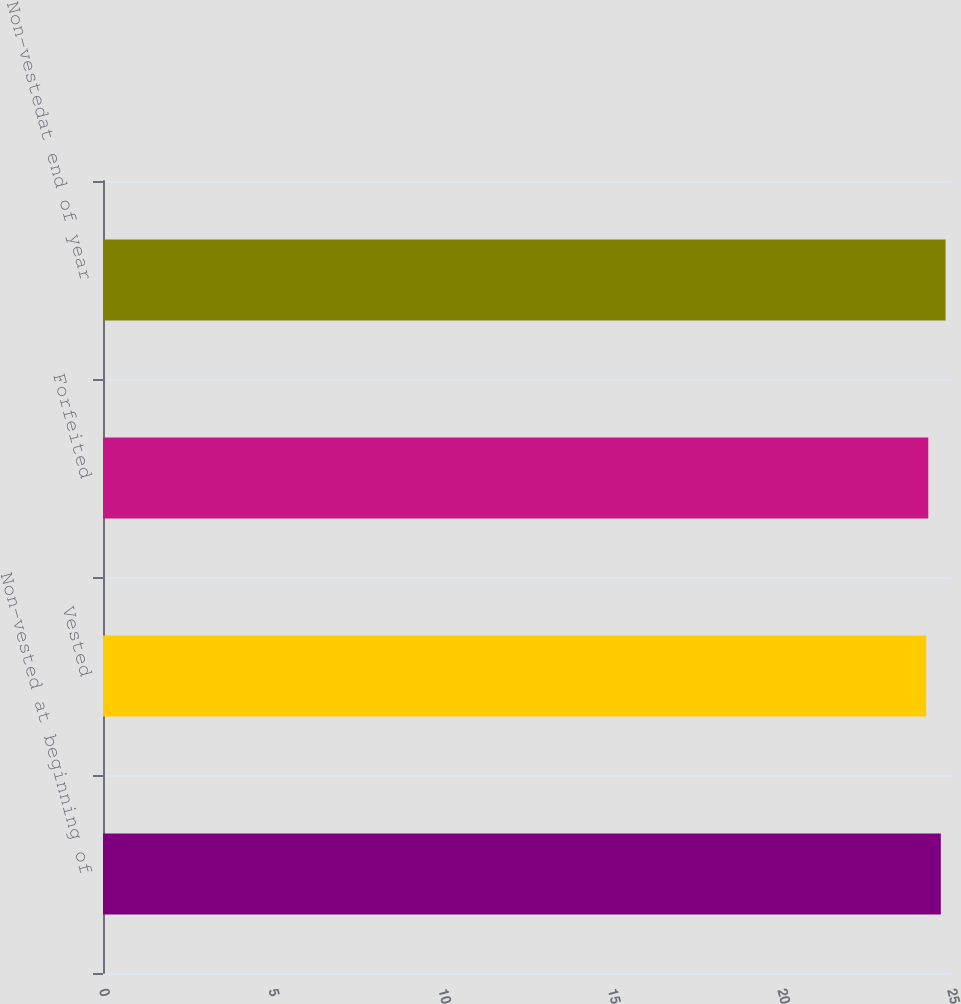Convert chart to OTSL. <chart><loc_0><loc_0><loc_500><loc_500><bar_chart><fcel>Non-vested at beginning of<fcel>Vested<fcel>Forfeited<fcel>Non-vestedat end of year<nl><fcel>24.7<fcel>24.27<fcel>24.33<fcel>24.84<nl></chart> 